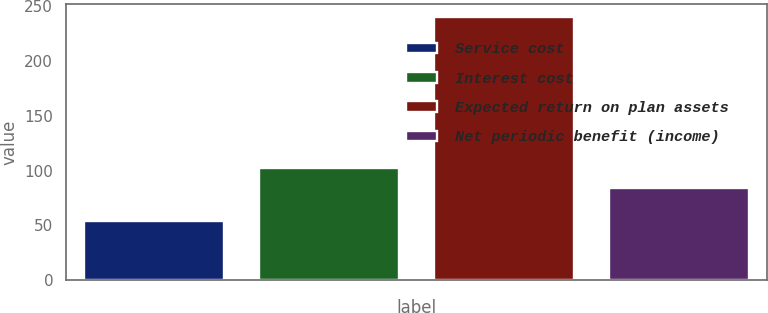Convert chart to OTSL. <chart><loc_0><loc_0><loc_500><loc_500><bar_chart><fcel>Service cost<fcel>Interest cost<fcel>Expected return on plan assets<fcel>Net periodic benefit (income)<nl><fcel>54<fcel>102.6<fcel>240<fcel>84<nl></chart> 